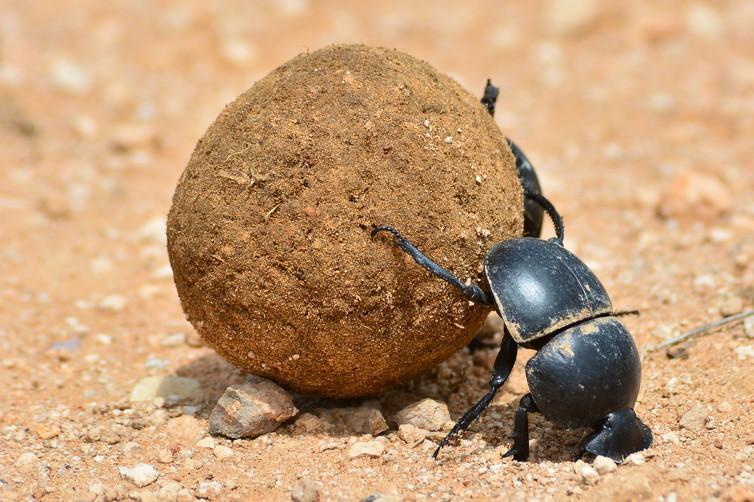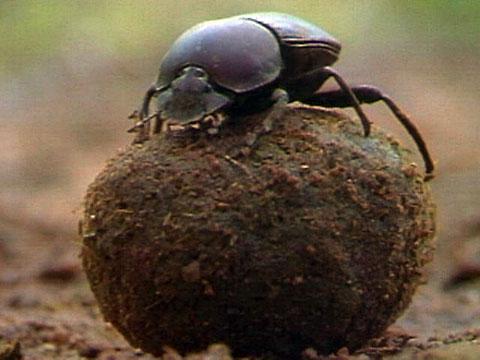The first image is the image on the left, the second image is the image on the right. Given the left and right images, does the statement "Images show a total of two beetles and two dung balls." hold true? Answer yes or no. Yes. 